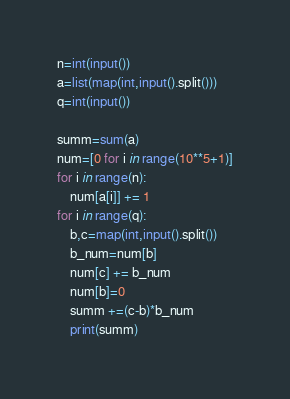Convert code to text. <code><loc_0><loc_0><loc_500><loc_500><_Python_>n=int(input())
a=list(map(int,input().split()))
q=int(input())

summ=sum(a)
num=[0 for i in range(10**5+1)]
for i in range(n):
    num[a[i]] += 1
for i in range(q):
    b,c=map(int,input().split())
    b_num=num[b]
    num[c] += b_num
    num[b]=0
    summ +=(c-b)*b_num
    print(summ)</code> 